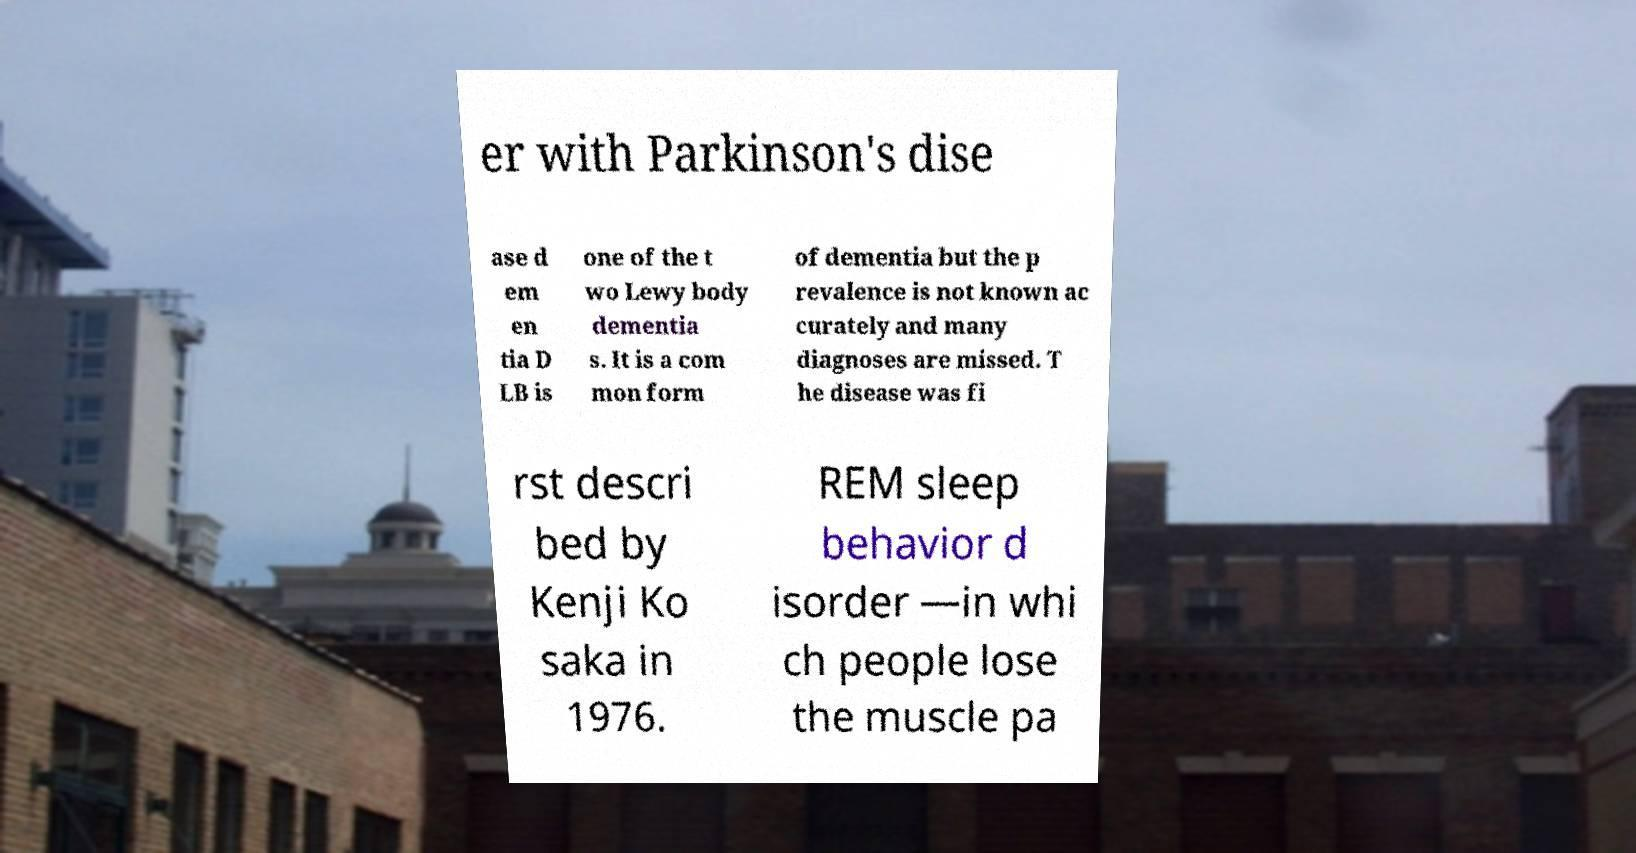Can you accurately transcribe the text from the provided image for me? er with Parkinson's dise ase d em en tia D LB is one of the t wo Lewy body dementia s. It is a com mon form of dementia but the p revalence is not known ac curately and many diagnoses are missed. T he disease was fi rst descri bed by Kenji Ko saka in 1976. REM sleep behavior d isorder —in whi ch people lose the muscle pa 